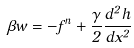Convert formula to latex. <formula><loc_0><loc_0><loc_500><loc_500>\beta w = - f ^ { n } + \frac { \gamma } { 2 } \frac { d ^ { 2 } h } { d x ^ { 2 } }</formula> 